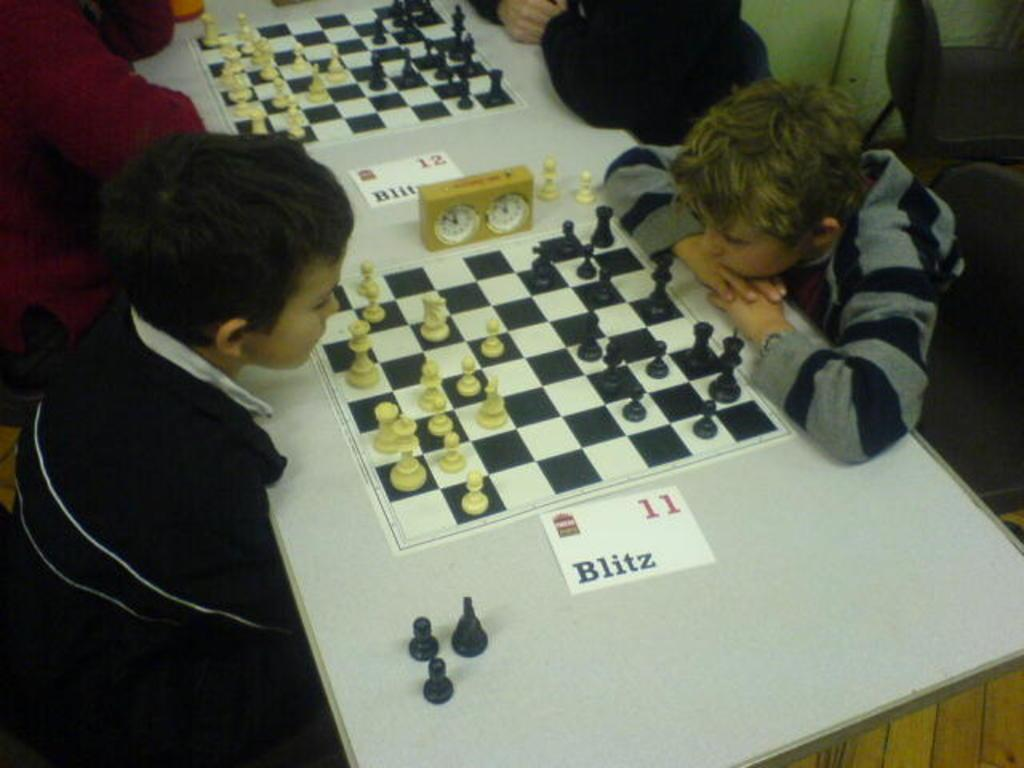What is the main object in the image? There is a table in the image. What is on top of the table? The table has a chess board on it. Who is present around the table? There are kids sitting around the table. Are the kids wearing masks while playing chess in the image? There is no mention of masks in the image, so we cannot determine if the kids are wearing them or not. 